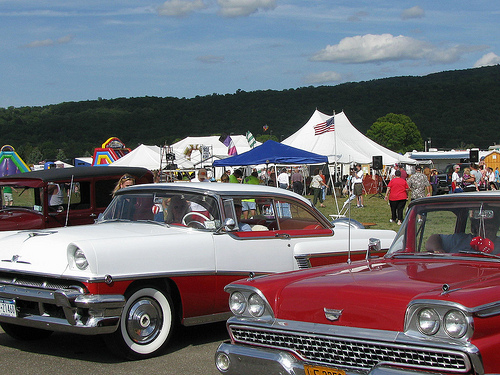<image>
Can you confirm if the man is on the car? No. The man is not positioned on the car. They may be near each other, but the man is not supported by or resting on top of the car. Is there a woman in front of the car? No. The woman is not in front of the car. The spatial positioning shows a different relationship between these objects. 